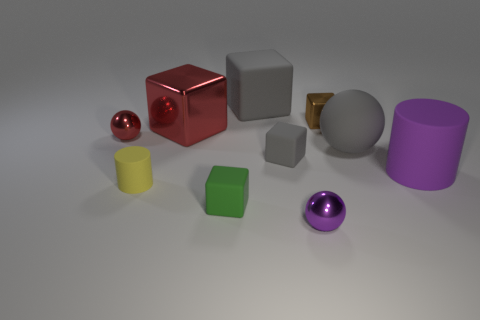What number of big things are green rubber blocks or cyan rubber cylinders?
Your response must be concise. 0. How big is the yellow matte object?
Make the answer very short. Small. How many small green rubber things are in front of the yellow object?
Your response must be concise. 1. The brown shiny object that is the same shape as the small green thing is what size?
Make the answer very short. Small. There is a metallic thing that is to the right of the small green matte block and behind the big purple rubber cylinder; what is its size?
Offer a very short reply. Small. Do the large cylinder and the shiny sphere right of the red metallic block have the same color?
Keep it short and to the point. Yes. What number of blue things are either shiny balls or small blocks?
Make the answer very short. 0. What is the shape of the big purple object?
Offer a terse response. Cylinder. What number of other things are the same shape as the brown object?
Provide a succinct answer. 4. What is the color of the small matte block to the right of the large gray block?
Your answer should be compact. Gray. 